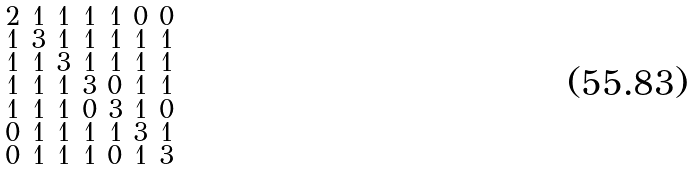<formula> <loc_0><loc_0><loc_500><loc_500>\begin{smallmatrix} 2 & 1 & 1 & 1 & 1 & 0 & 0 \\ 1 & 3 & 1 & 1 & 1 & 1 & 1 \\ 1 & 1 & 3 & 1 & 1 & 1 & 1 \\ 1 & 1 & 1 & 3 & 0 & 1 & 1 \\ 1 & 1 & 1 & 0 & 3 & 1 & 0 \\ 0 & 1 & 1 & 1 & 1 & 3 & 1 \\ 0 & 1 & 1 & 1 & 0 & 1 & 3 \end{smallmatrix}</formula> 